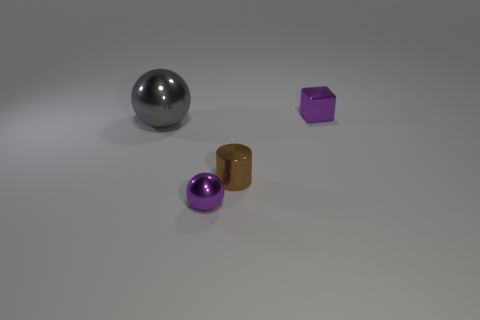What shape is the brown thing that is the same material as the small purple cube?
Provide a succinct answer. Cylinder. Is there anything else that is the same color as the big thing?
Your response must be concise. No. Are there more shiny spheres right of the large sphere than red metallic cubes?
Ensure brevity in your answer.  Yes. What is the cube made of?
Ensure brevity in your answer.  Metal. What number of other cylinders have the same size as the brown shiny cylinder?
Provide a short and direct response. 0. Are there an equal number of tiny brown shiny cylinders to the right of the cylinder and tiny shiny blocks that are in front of the large thing?
Offer a terse response. Yes. Is the purple ball made of the same material as the brown object?
Provide a short and direct response. Yes. There is a tiny purple object on the left side of the purple cube; is there a object behind it?
Your answer should be very brief. Yes. Are there any large red things of the same shape as the tiny brown object?
Your response must be concise. No. Is the cube the same color as the small ball?
Keep it short and to the point. Yes. 